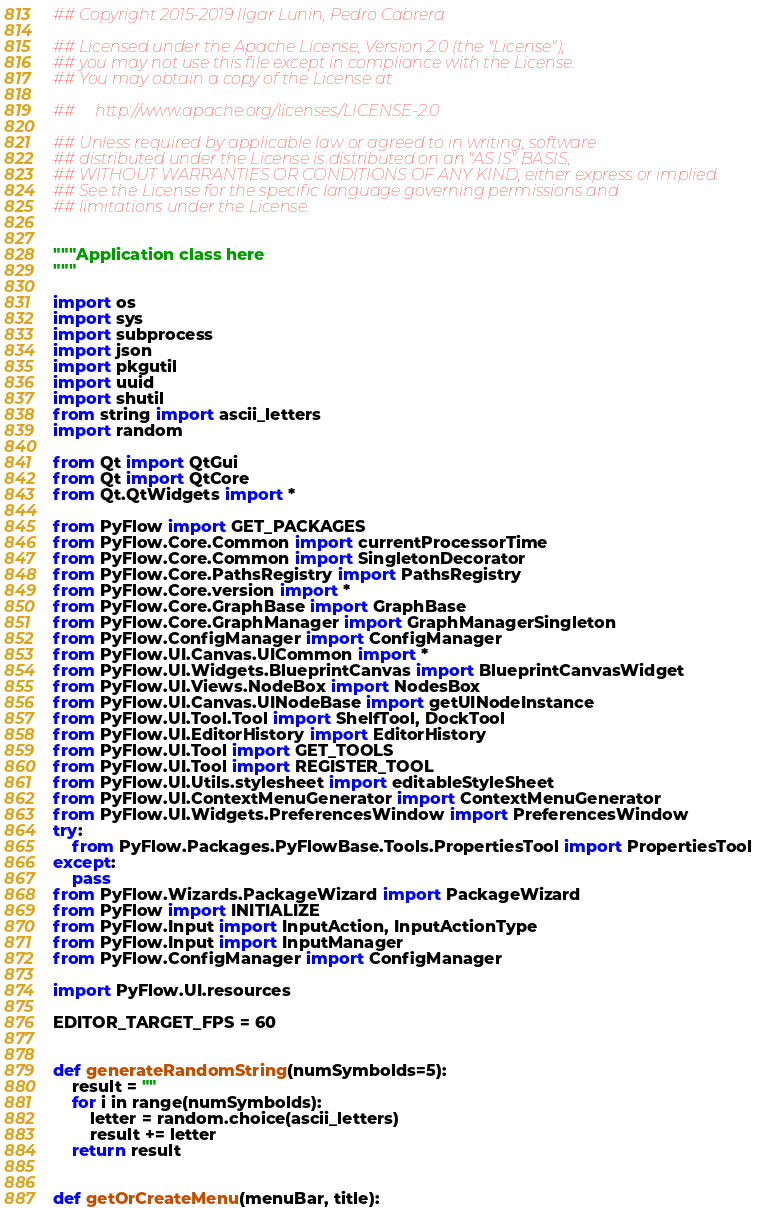Convert code to text. <code><loc_0><loc_0><loc_500><loc_500><_Python_>## Copyright 2015-2019 Ilgar Lunin, Pedro Cabrera

## Licensed under the Apache License, Version 2.0 (the "License");
## you may not use this file except in compliance with the License.
## You may obtain a copy of the License at

##     http://www.apache.org/licenses/LICENSE-2.0

## Unless required by applicable law or agreed to in writing, software
## distributed under the License is distributed on an "AS IS" BASIS,
## WITHOUT WARRANTIES OR CONDITIONS OF ANY KIND, either express or implied.
## See the License for the specific language governing permissions and
## limitations under the License.


"""Application class here
"""

import os
import sys
import subprocess
import json
import pkgutil
import uuid
import shutil
from string import ascii_letters
import random

from Qt import QtGui
from Qt import QtCore
from Qt.QtWidgets import *

from PyFlow import GET_PACKAGES
from PyFlow.Core.Common import currentProcessorTime
from PyFlow.Core.Common import SingletonDecorator
from PyFlow.Core.PathsRegistry import PathsRegistry
from PyFlow.Core.version import *
from PyFlow.Core.GraphBase import GraphBase
from PyFlow.Core.GraphManager import GraphManagerSingleton
from PyFlow.ConfigManager import ConfigManager
from PyFlow.UI.Canvas.UICommon import *
from PyFlow.UI.Widgets.BlueprintCanvas import BlueprintCanvasWidget
from PyFlow.UI.Views.NodeBox import NodesBox
from PyFlow.UI.Canvas.UINodeBase import getUINodeInstance
from PyFlow.UI.Tool.Tool import ShelfTool, DockTool
from PyFlow.UI.EditorHistory import EditorHistory
from PyFlow.UI.Tool import GET_TOOLS
from PyFlow.UI.Tool import REGISTER_TOOL
from PyFlow.UI.Utils.stylesheet import editableStyleSheet
from PyFlow.UI.ContextMenuGenerator import ContextMenuGenerator
from PyFlow.UI.Widgets.PreferencesWindow import PreferencesWindow
try:
    from PyFlow.Packages.PyFlowBase.Tools.PropertiesTool import PropertiesTool
except:
    pass
from PyFlow.Wizards.PackageWizard import PackageWizard
from PyFlow import INITIALIZE
from PyFlow.Input import InputAction, InputActionType
from PyFlow.Input import InputManager
from PyFlow.ConfigManager import ConfigManager

import PyFlow.UI.resources

EDITOR_TARGET_FPS = 60


def generateRandomString(numSymbolds=5):
    result = ""
    for i in range(numSymbolds):
        letter = random.choice(ascii_letters)
        result += letter
    return result


def getOrCreateMenu(menuBar, title):</code> 